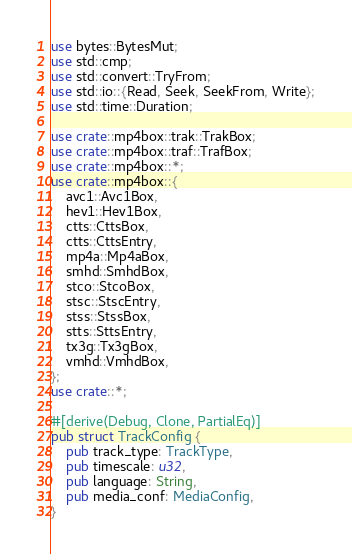Convert code to text. <code><loc_0><loc_0><loc_500><loc_500><_Rust_>use bytes::BytesMut;
use std::cmp;
use std::convert::TryFrom;
use std::io::{Read, Seek, SeekFrom, Write};
use std::time::Duration;

use crate::mp4box::trak::TrakBox;
use crate::mp4box::traf::TrafBox;
use crate::mp4box::*;
use crate::mp4box::{
    avc1::Avc1Box,
    hev1::Hev1Box,
    ctts::CttsBox,
    ctts::CttsEntry,
    mp4a::Mp4aBox,
    smhd::SmhdBox,
    stco::StcoBox,
    stsc::StscEntry,
    stss::StssBox,
    stts::SttsEntry,
    tx3g::Tx3gBox,
    vmhd::VmhdBox,
};
use crate::*;

#[derive(Debug, Clone, PartialEq)]
pub struct TrackConfig {
    pub track_type: TrackType,
    pub timescale: u32,
    pub language: String,
    pub media_conf: MediaConfig,
}
</code> 